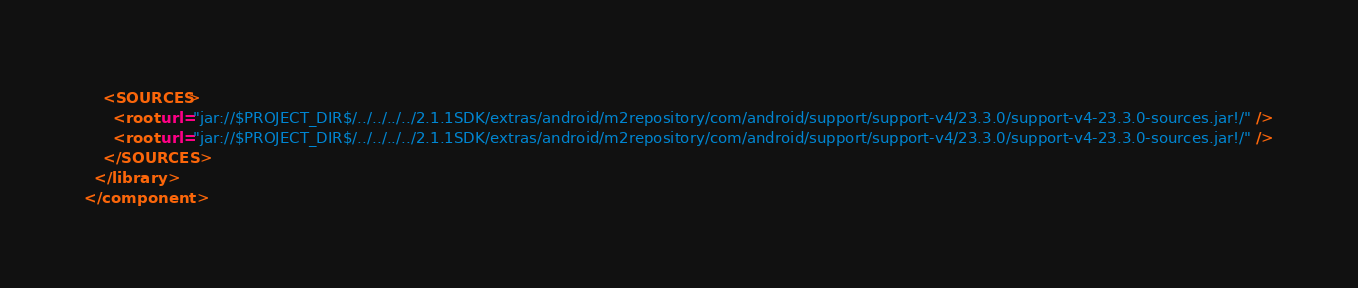<code> <loc_0><loc_0><loc_500><loc_500><_XML_>    <SOURCES>
      <root url="jar://$PROJECT_DIR$/../../../../2.1.1SDK/extras/android/m2repository/com/android/support/support-v4/23.3.0/support-v4-23.3.0-sources.jar!/" />
      <root url="jar://$PROJECT_DIR$/../../../../2.1.1SDK/extras/android/m2repository/com/android/support/support-v4/23.3.0/support-v4-23.3.0-sources.jar!/" />
    </SOURCES>
  </library>
</component></code> 